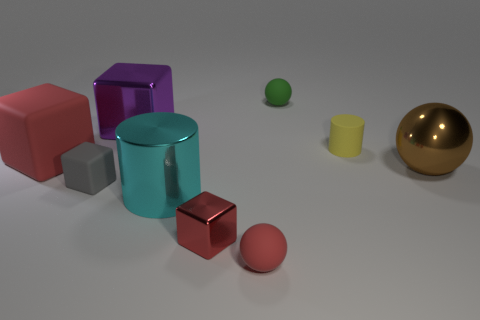Do the large rubber object and the shiny cube that is on the right side of the purple cube have the same color?
Make the answer very short. Yes. There is a big cube behind the yellow rubber cylinder; how many large purple metal cubes are left of it?
Provide a short and direct response. 0. What is the shape of the thing that is both left of the small red cube and behind the large red matte object?
Offer a terse response. Cube. What number of objects have the same color as the small metallic block?
Make the answer very short. 2. Is there a shiny object in front of the rubber thing that is right of the small object behind the tiny yellow rubber thing?
Give a very brief answer. Yes. How big is the metal thing that is behind the small rubber cube and on the right side of the cyan metal cylinder?
Your answer should be very brief. Large. How many small red cubes are made of the same material as the gray object?
Keep it short and to the point. 0. What number of cylinders are cyan shiny things or brown metallic objects?
Your response must be concise. 1. There is a metallic cube behind the red object behind the metal thing in front of the big cyan cylinder; what is its size?
Your response must be concise. Large. There is a small object that is in front of the big metallic ball and right of the tiny red block; what color is it?
Provide a succinct answer. Red. 